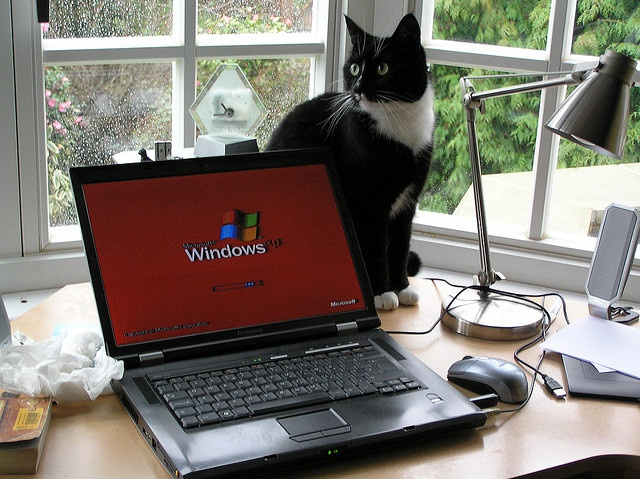Describe the objects in this image and their specific colors. I can see laptop in gray, maroon, black, and lightgray tones, cat in gray, black, darkgray, and lightgray tones, keyboard in gray, black, and purple tones, clock in gray, lightgray, and darkgray tones, and book in gray, tan, and black tones in this image. 